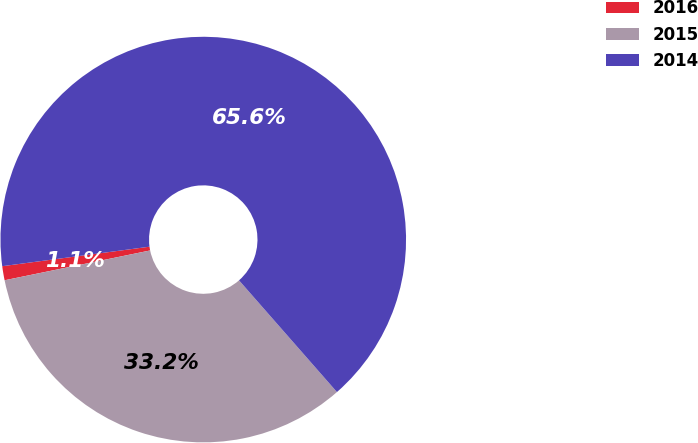<chart> <loc_0><loc_0><loc_500><loc_500><pie_chart><fcel>2016<fcel>2015<fcel>2014<nl><fcel>1.12%<fcel>33.24%<fcel>65.64%<nl></chart> 